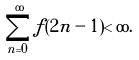Convert formula to latex. <formula><loc_0><loc_0><loc_500><loc_500>\sum _ { n = 0 } ^ { \infty } f ( 2 n - 1 ) < \infty .</formula> 